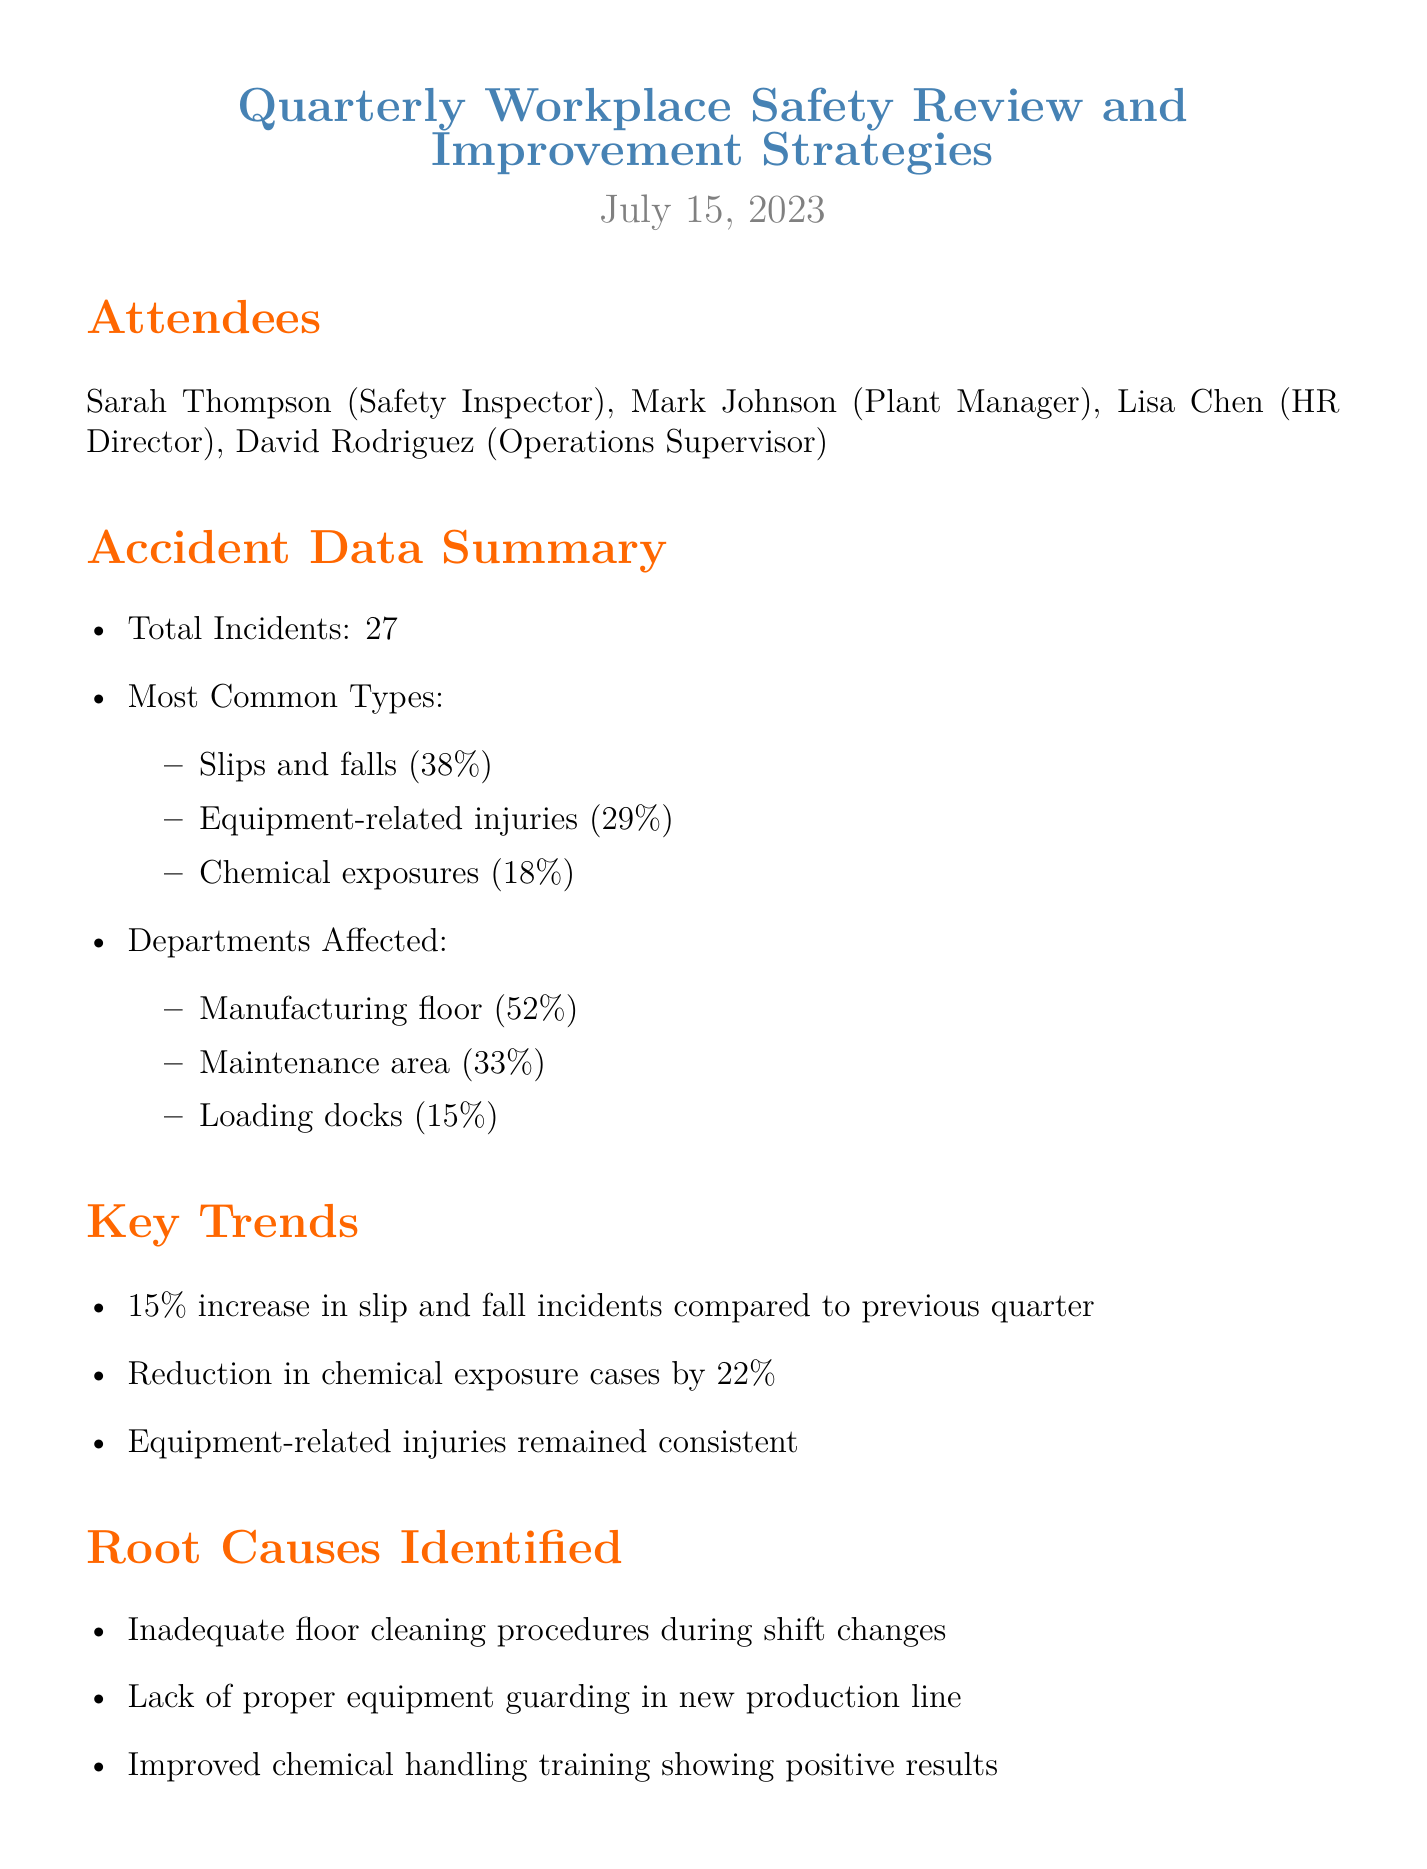What was the date of the meeting? The date of the meeting is specified in the document header as July 15, 2023.
Answer: July 15, 2023 How many total incidents were reported? The document states that there were a total of 27 incidents reported in the accident data summary.
Answer: 27 What percentage of incidents were slips and falls? The document lists slips and falls as 38% of the total incidents.
Answer: 38% What is one root cause identified for accidents? The document mentions inadequate floor cleaning procedures during shift changes as one of the root causes identified.
Answer: Inadequate floor cleaning procedures during shift changes Who is responsible for implementing anti-slip flooring? The document assigns Mark Johnson as responsible for implementing anti-slip flooring in high-risk areas.
Answer: Mark Johnson What is the deadline for the equipment safety audit? The equipment safety audit is assigned to be completed by August 15, 2023, according to the proposed improvement strategies section.
Answer: August 15, 2023 What trend was observed in chemical exposure cases? The document notes a reduction in chemical exposure cases by 22% compared to the previous quarter.
Answer: Reduction in chemical exposure cases by 22% What percentage of incidents occurred on the manufacturing floor? The accidents summary indicates that 52% of incidents occurred on the manufacturing floor.
Answer: 52% What is one action item suggested in the meeting? The document lists scheduling weekly safety walks with department heads as one of the action items suggested.
Answer: Schedule weekly safety walks with department heads 